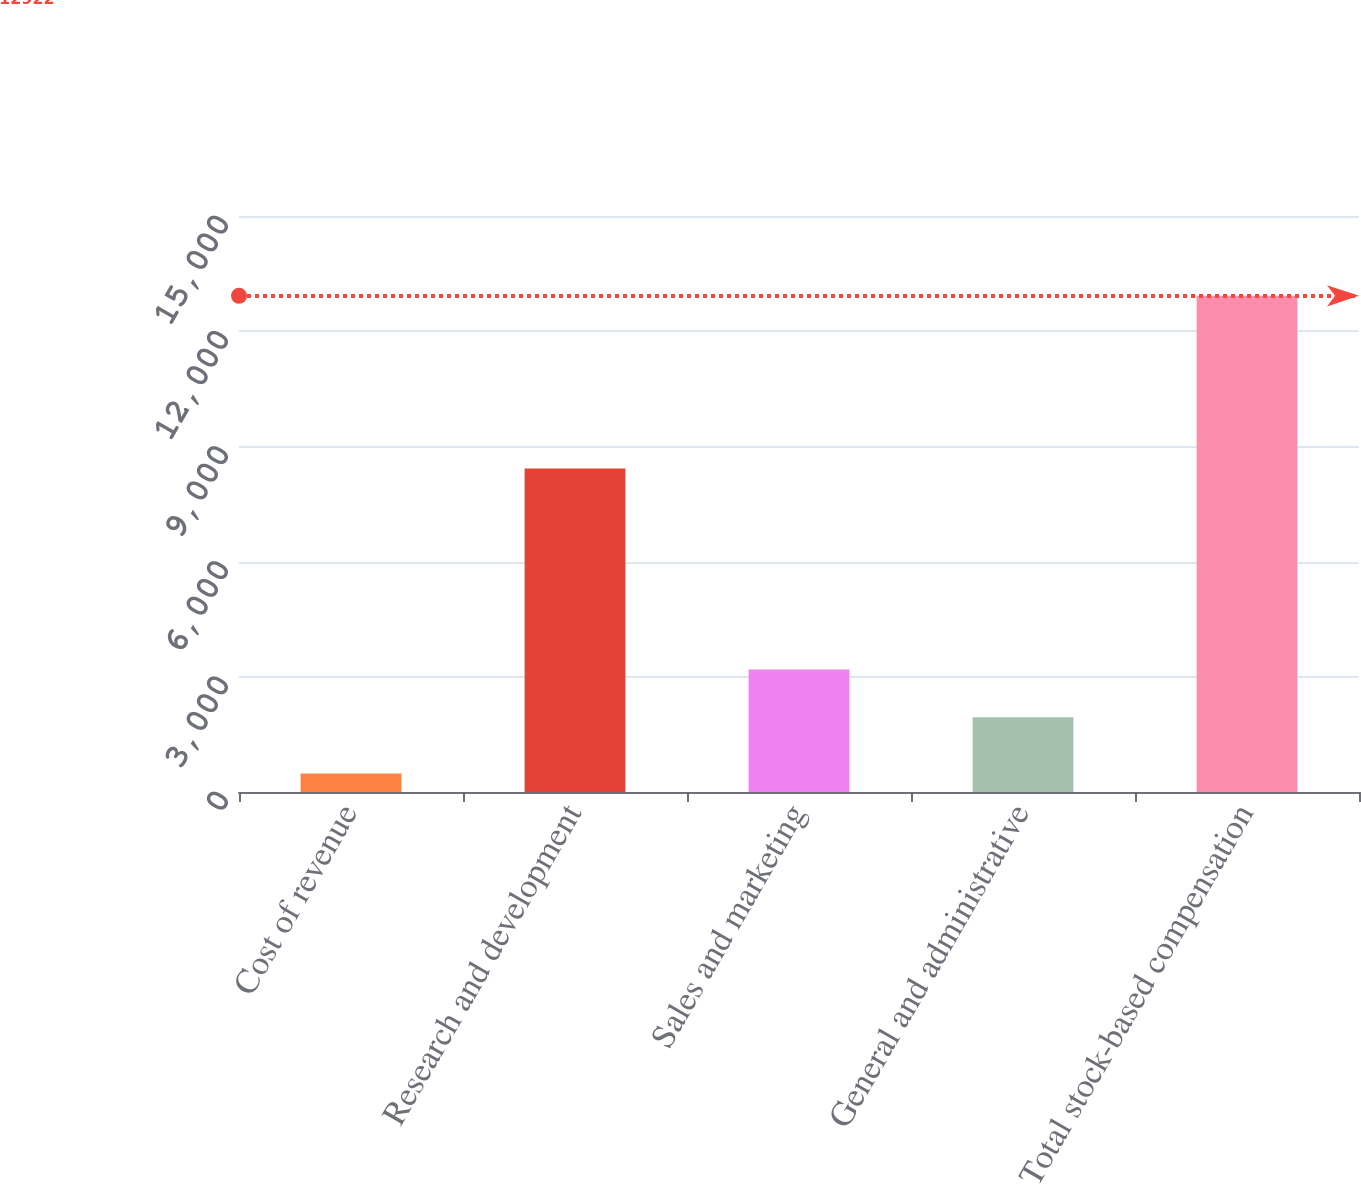<chart> <loc_0><loc_0><loc_500><loc_500><bar_chart><fcel>Cost of revenue<fcel>Research and development<fcel>Sales and marketing<fcel>General and administrative<fcel>Total stock-based compensation<nl><fcel>484<fcel>8425<fcel>3191.8<fcel>1948<fcel>12922<nl></chart> 